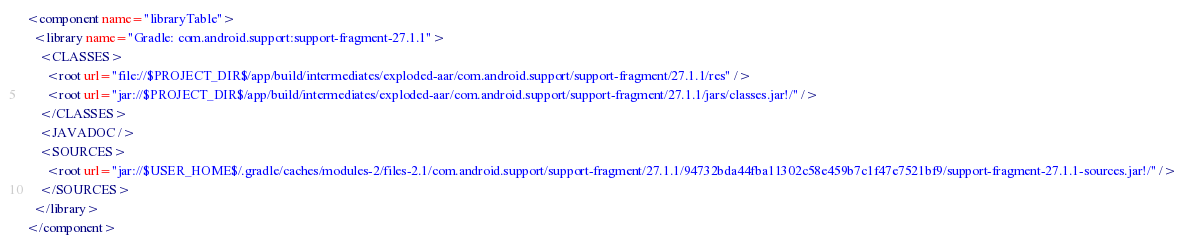<code> <loc_0><loc_0><loc_500><loc_500><_XML_><component name="libraryTable">
  <library name="Gradle: com.android.support:support-fragment-27.1.1">
    <CLASSES>
      <root url="file://$PROJECT_DIR$/app/build/intermediates/exploded-aar/com.android.support/support-fragment/27.1.1/res" />
      <root url="jar://$PROJECT_DIR$/app/build/intermediates/exploded-aar/com.android.support/support-fragment/27.1.1/jars/classes.jar!/" />
    </CLASSES>
    <JAVADOC />
    <SOURCES>
      <root url="jar://$USER_HOME$/.gradle/caches/modules-2/files-2.1/com.android.support/support-fragment/27.1.1/94732bda44fba11302c58e459b7c1f47e7521bf9/support-fragment-27.1.1-sources.jar!/" />
    </SOURCES>
  </library>
</component></code> 